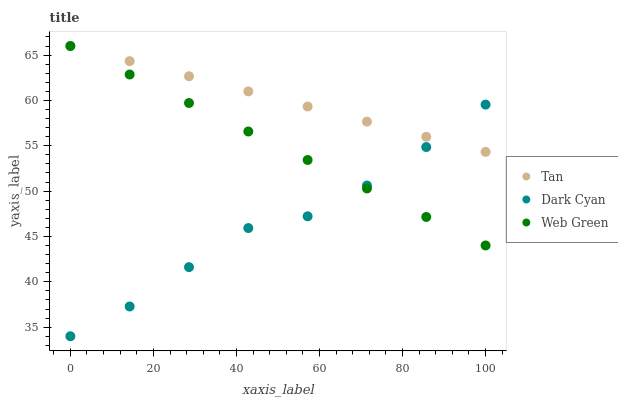Does Dark Cyan have the minimum area under the curve?
Answer yes or no. Yes. Does Tan have the maximum area under the curve?
Answer yes or no. Yes. Does Web Green have the minimum area under the curve?
Answer yes or no. No. Does Web Green have the maximum area under the curve?
Answer yes or no. No. Is Web Green the smoothest?
Answer yes or no. Yes. Is Dark Cyan the roughest?
Answer yes or no. Yes. Is Tan the smoothest?
Answer yes or no. No. Is Tan the roughest?
Answer yes or no. No. Does Dark Cyan have the lowest value?
Answer yes or no. Yes. Does Web Green have the lowest value?
Answer yes or no. No. Does Web Green have the highest value?
Answer yes or no. Yes. Does Dark Cyan intersect Tan?
Answer yes or no. Yes. Is Dark Cyan less than Tan?
Answer yes or no. No. Is Dark Cyan greater than Tan?
Answer yes or no. No. 